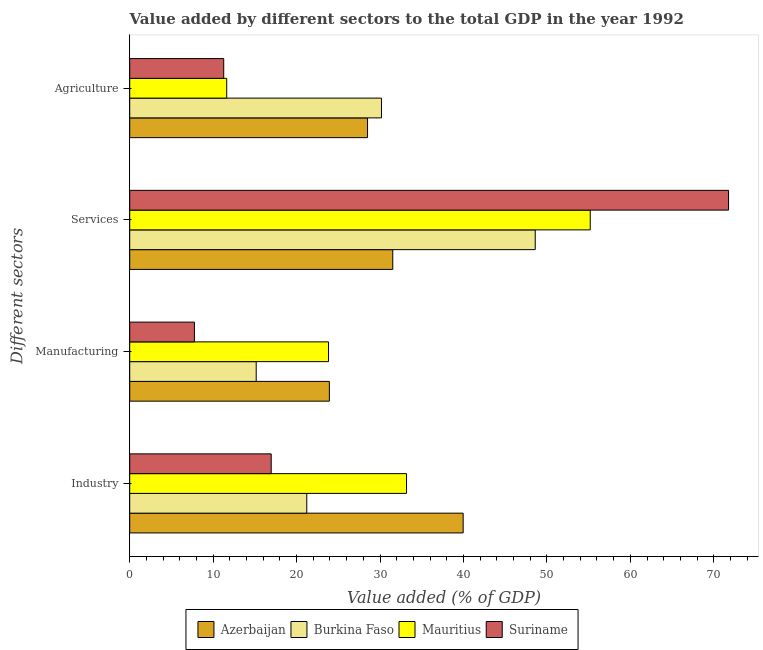How many different coloured bars are there?
Ensure brevity in your answer.  4. How many groups of bars are there?
Provide a succinct answer. 4. Are the number of bars per tick equal to the number of legend labels?
Ensure brevity in your answer.  Yes. How many bars are there on the 2nd tick from the top?
Your answer should be very brief. 4. How many bars are there on the 3rd tick from the bottom?
Keep it short and to the point. 4. What is the label of the 2nd group of bars from the top?
Keep it short and to the point. Services. What is the value added by services sector in Mauritius?
Give a very brief answer. 55.2. Across all countries, what is the maximum value added by manufacturing sector?
Your answer should be very brief. 23.93. Across all countries, what is the minimum value added by services sector?
Your answer should be compact. 31.53. In which country was the value added by services sector maximum?
Provide a succinct answer. Suriname. In which country was the value added by agricultural sector minimum?
Give a very brief answer. Suriname. What is the total value added by agricultural sector in the graph?
Your answer should be very brief. 81.57. What is the difference between the value added by industrial sector in Suriname and that in Burkina Faso?
Your answer should be compact. -4.26. What is the difference between the value added by agricultural sector in Burkina Faso and the value added by manufacturing sector in Suriname?
Your answer should be compact. 22.42. What is the average value added by manufacturing sector per country?
Give a very brief answer. 17.67. What is the difference between the value added by industrial sector and value added by agricultural sector in Mauritius?
Your answer should be very brief. 21.55. What is the ratio of the value added by manufacturing sector in Mauritius to that in Azerbaijan?
Ensure brevity in your answer.  1. Is the value added by industrial sector in Suriname less than that in Mauritius?
Your answer should be very brief. Yes. Is the difference between the value added by industrial sector in Burkina Faso and Azerbaijan greater than the difference between the value added by agricultural sector in Burkina Faso and Azerbaijan?
Ensure brevity in your answer.  No. What is the difference between the highest and the second highest value added by agricultural sector?
Your answer should be very brief. 1.67. What is the difference between the highest and the lowest value added by industrial sector?
Make the answer very short. 23.01. In how many countries, is the value added by agricultural sector greater than the average value added by agricultural sector taken over all countries?
Your response must be concise. 2. Is the sum of the value added by industrial sector in Mauritius and Suriname greater than the maximum value added by manufacturing sector across all countries?
Provide a short and direct response. Yes. Is it the case that in every country, the sum of the value added by services sector and value added by agricultural sector is greater than the sum of value added by manufacturing sector and value added by industrial sector?
Keep it short and to the point. Yes. What does the 2nd bar from the top in Manufacturing represents?
Your answer should be compact. Mauritius. What does the 2nd bar from the bottom in Services represents?
Ensure brevity in your answer.  Burkina Faso. Is it the case that in every country, the sum of the value added by industrial sector and value added by manufacturing sector is greater than the value added by services sector?
Provide a succinct answer. No. How many bars are there?
Provide a succinct answer. 16. Does the graph contain grids?
Your response must be concise. No. Where does the legend appear in the graph?
Give a very brief answer. Bottom center. How many legend labels are there?
Ensure brevity in your answer.  4. What is the title of the graph?
Offer a terse response. Value added by different sectors to the total GDP in the year 1992. What is the label or title of the X-axis?
Provide a succinct answer. Value added (% of GDP). What is the label or title of the Y-axis?
Your response must be concise. Different sectors. What is the Value added (% of GDP) of Azerbaijan in Industry?
Offer a terse response. 39.97. What is the Value added (% of GDP) in Burkina Faso in Industry?
Provide a succinct answer. 21.22. What is the Value added (% of GDP) in Mauritius in Industry?
Ensure brevity in your answer.  33.18. What is the Value added (% of GDP) of Suriname in Industry?
Provide a succinct answer. 16.96. What is the Value added (% of GDP) in Azerbaijan in Manufacturing?
Give a very brief answer. 23.93. What is the Value added (% of GDP) in Burkina Faso in Manufacturing?
Offer a terse response. 15.16. What is the Value added (% of GDP) of Mauritius in Manufacturing?
Offer a very short reply. 23.83. What is the Value added (% of GDP) in Suriname in Manufacturing?
Your response must be concise. 7.76. What is the Value added (% of GDP) of Azerbaijan in Services?
Provide a succinct answer. 31.53. What is the Value added (% of GDP) of Burkina Faso in Services?
Make the answer very short. 48.61. What is the Value added (% of GDP) in Mauritius in Services?
Your answer should be compact. 55.2. What is the Value added (% of GDP) of Suriname in Services?
Provide a succinct answer. 71.78. What is the Value added (% of GDP) in Azerbaijan in Agriculture?
Make the answer very short. 28.51. What is the Value added (% of GDP) in Burkina Faso in Agriculture?
Keep it short and to the point. 30.17. What is the Value added (% of GDP) of Mauritius in Agriculture?
Provide a succinct answer. 11.63. What is the Value added (% of GDP) of Suriname in Agriculture?
Your answer should be very brief. 11.27. Across all Different sectors, what is the maximum Value added (% of GDP) of Azerbaijan?
Keep it short and to the point. 39.97. Across all Different sectors, what is the maximum Value added (% of GDP) in Burkina Faso?
Keep it short and to the point. 48.61. Across all Different sectors, what is the maximum Value added (% of GDP) of Mauritius?
Keep it short and to the point. 55.2. Across all Different sectors, what is the maximum Value added (% of GDP) of Suriname?
Keep it short and to the point. 71.78. Across all Different sectors, what is the minimum Value added (% of GDP) of Azerbaijan?
Offer a terse response. 23.93. Across all Different sectors, what is the minimum Value added (% of GDP) in Burkina Faso?
Provide a short and direct response. 15.16. Across all Different sectors, what is the minimum Value added (% of GDP) in Mauritius?
Make the answer very short. 11.63. Across all Different sectors, what is the minimum Value added (% of GDP) in Suriname?
Offer a terse response. 7.76. What is the total Value added (% of GDP) in Azerbaijan in the graph?
Give a very brief answer. 123.93. What is the total Value added (% of GDP) in Burkina Faso in the graph?
Ensure brevity in your answer.  115.16. What is the total Value added (% of GDP) in Mauritius in the graph?
Your answer should be very brief. 123.83. What is the total Value added (% of GDP) of Suriname in the graph?
Make the answer very short. 107.75. What is the difference between the Value added (% of GDP) in Azerbaijan in Industry and that in Manufacturing?
Ensure brevity in your answer.  16.04. What is the difference between the Value added (% of GDP) in Burkina Faso in Industry and that in Manufacturing?
Give a very brief answer. 6.06. What is the difference between the Value added (% of GDP) of Mauritius in Industry and that in Manufacturing?
Offer a terse response. 9.35. What is the difference between the Value added (% of GDP) in Suriname in Industry and that in Manufacturing?
Your response must be concise. 9.2. What is the difference between the Value added (% of GDP) in Azerbaijan in Industry and that in Services?
Make the answer very short. 8.44. What is the difference between the Value added (% of GDP) in Burkina Faso in Industry and that in Services?
Make the answer very short. -27.39. What is the difference between the Value added (% of GDP) of Mauritius in Industry and that in Services?
Give a very brief answer. -22.02. What is the difference between the Value added (% of GDP) of Suriname in Industry and that in Services?
Provide a succinct answer. -54.82. What is the difference between the Value added (% of GDP) of Azerbaijan in Industry and that in Agriculture?
Ensure brevity in your answer.  11.46. What is the difference between the Value added (% of GDP) in Burkina Faso in Industry and that in Agriculture?
Provide a succinct answer. -8.96. What is the difference between the Value added (% of GDP) in Mauritius in Industry and that in Agriculture?
Provide a short and direct response. 21.55. What is the difference between the Value added (% of GDP) of Suriname in Industry and that in Agriculture?
Keep it short and to the point. 5.69. What is the difference between the Value added (% of GDP) of Azerbaijan in Manufacturing and that in Services?
Offer a terse response. -7.6. What is the difference between the Value added (% of GDP) of Burkina Faso in Manufacturing and that in Services?
Give a very brief answer. -33.45. What is the difference between the Value added (% of GDP) of Mauritius in Manufacturing and that in Services?
Ensure brevity in your answer.  -31.37. What is the difference between the Value added (% of GDP) of Suriname in Manufacturing and that in Services?
Your answer should be compact. -64.02. What is the difference between the Value added (% of GDP) of Azerbaijan in Manufacturing and that in Agriculture?
Make the answer very short. -4.58. What is the difference between the Value added (% of GDP) in Burkina Faso in Manufacturing and that in Agriculture?
Your answer should be compact. -15.02. What is the difference between the Value added (% of GDP) in Mauritius in Manufacturing and that in Agriculture?
Your response must be concise. 12.2. What is the difference between the Value added (% of GDP) in Suriname in Manufacturing and that in Agriculture?
Make the answer very short. -3.51. What is the difference between the Value added (% of GDP) of Azerbaijan in Services and that in Agriculture?
Your response must be concise. 3.02. What is the difference between the Value added (% of GDP) of Burkina Faso in Services and that in Agriculture?
Your answer should be compact. 18.43. What is the difference between the Value added (% of GDP) of Mauritius in Services and that in Agriculture?
Make the answer very short. 43.57. What is the difference between the Value added (% of GDP) of Suriname in Services and that in Agriculture?
Make the answer very short. 60.51. What is the difference between the Value added (% of GDP) of Azerbaijan in Industry and the Value added (% of GDP) of Burkina Faso in Manufacturing?
Your answer should be compact. 24.81. What is the difference between the Value added (% of GDP) in Azerbaijan in Industry and the Value added (% of GDP) in Mauritius in Manufacturing?
Provide a succinct answer. 16.14. What is the difference between the Value added (% of GDP) in Azerbaijan in Industry and the Value added (% of GDP) in Suriname in Manufacturing?
Your answer should be very brief. 32.21. What is the difference between the Value added (% of GDP) of Burkina Faso in Industry and the Value added (% of GDP) of Mauritius in Manufacturing?
Offer a very short reply. -2.61. What is the difference between the Value added (% of GDP) in Burkina Faso in Industry and the Value added (% of GDP) in Suriname in Manufacturing?
Your answer should be very brief. 13.46. What is the difference between the Value added (% of GDP) of Mauritius in Industry and the Value added (% of GDP) of Suriname in Manufacturing?
Provide a short and direct response. 25.42. What is the difference between the Value added (% of GDP) in Azerbaijan in Industry and the Value added (% of GDP) in Burkina Faso in Services?
Your answer should be very brief. -8.64. What is the difference between the Value added (% of GDP) of Azerbaijan in Industry and the Value added (% of GDP) of Mauritius in Services?
Your response must be concise. -15.23. What is the difference between the Value added (% of GDP) in Azerbaijan in Industry and the Value added (% of GDP) in Suriname in Services?
Keep it short and to the point. -31.81. What is the difference between the Value added (% of GDP) of Burkina Faso in Industry and the Value added (% of GDP) of Mauritius in Services?
Your answer should be compact. -33.98. What is the difference between the Value added (% of GDP) of Burkina Faso in Industry and the Value added (% of GDP) of Suriname in Services?
Give a very brief answer. -50.56. What is the difference between the Value added (% of GDP) of Mauritius in Industry and the Value added (% of GDP) of Suriname in Services?
Your answer should be very brief. -38.6. What is the difference between the Value added (% of GDP) in Azerbaijan in Industry and the Value added (% of GDP) in Burkina Faso in Agriculture?
Your response must be concise. 9.79. What is the difference between the Value added (% of GDP) in Azerbaijan in Industry and the Value added (% of GDP) in Mauritius in Agriculture?
Make the answer very short. 28.34. What is the difference between the Value added (% of GDP) of Azerbaijan in Industry and the Value added (% of GDP) of Suriname in Agriculture?
Your answer should be compact. 28.7. What is the difference between the Value added (% of GDP) in Burkina Faso in Industry and the Value added (% of GDP) in Mauritius in Agriculture?
Your answer should be compact. 9.59. What is the difference between the Value added (% of GDP) in Burkina Faso in Industry and the Value added (% of GDP) in Suriname in Agriculture?
Provide a short and direct response. 9.95. What is the difference between the Value added (% of GDP) of Mauritius in Industry and the Value added (% of GDP) of Suriname in Agriculture?
Your answer should be very brief. 21.91. What is the difference between the Value added (% of GDP) of Azerbaijan in Manufacturing and the Value added (% of GDP) of Burkina Faso in Services?
Give a very brief answer. -24.67. What is the difference between the Value added (% of GDP) of Azerbaijan in Manufacturing and the Value added (% of GDP) of Mauritius in Services?
Keep it short and to the point. -31.27. What is the difference between the Value added (% of GDP) of Azerbaijan in Manufacturing and the Value added (% of GDP) of Suriname in Services?
Your response must be concise. -47.85. What is the difference between the Value added (% of GDP) in Burkina Faso in Manufacturing and the Value added (% of GDP) in Mauritius in Services?
Give a very brief answer. -40.04. What is the difference between the Value added (% of GDP) in Burkina Faso in Manufacturing and the Value added (% of GDP) in Suriname in Services?
Ensure brevity in your answer.  -56.62. What is the difference between the Value added (% of GDP) in Mauritius in Manufacturing and the Value added (% of GDP) in Suriname in Services?
Your answer should be very brief. -47.95. What is the difference between the Value added (% of GDP) of Azerbaijan in Manufacturing and the Value added (% of GDP) of Burkina Faso in Agriculture?
Your response must be concise. -6.24. What is the difference between the Value added (% of GDP) in Azerbaijan in Manufacturing and the Value added (% of GDP) in Mauritius in Agriculture?
Provide a succinct answer. 12.3. What is the difference between the Value added (% of GDP) in Azerbaijan in Manufacturing and the Value added (% of GDP) in Suriname in Agriculture?
Provide a succinct answer. 12.66. What is the difference between the Value added (% of GDP) in Burkina Faso in Manufacturing and the Value added (% of GDP) in Mauritius in Agriculture?
Provide a succinct answer. 3.53. What is the difference between the Value added (% of GDP) of Burkina Faso in Manufacturing and the Value added (% of GDP) of Suriname in Agriculture?
Offer a very short reply. 3.89. What is the difference between the Value added (% of GDP) in Mauritius in Manufacturing and the Value added (% of GDP) in Suriname in Agriculture?
Offer a very short reply. 12.56. What is the difference between the Value added (% of GDP) of Azerbaijan in Services and the Value added (% of GDP) of Burkina Faso in Agriculture?
Keep it short and to the point. 1.35. What is the difference between the Value added (% of GDP) in Azerbaijan in Services and the Value added (% of GDP) in Mauritius in Agriculture?
Provide a succinct answer. 19.9. What is the difference between the Value added (% of GDP) in Azerbaijan in Services and the Value added (% of GDP) in Suriname in Agriculture?
Offer a very short reply. 20.26. What is the difference between the Value added (% of GDP) in Burkina Faso in Services and the Value added (% of GDP) in Mauritius in Agriculture?
Offer a terse response. 36.98. What is the difference between the Value added (% of GDP) in Burkina Faso in Services and the Value added (% of GDP) in Suriname in Agriculture?
Provide a succinct answer. 37.34. What is the difference between the Value added (% of GDP) in Mauritius in Services and the Value added (% of GDP) in Suriname in Agriculture?
Keep it short and to the point. 43.93. What is the average Value added (% of GDP) of Azerbaijan per Different sectors?
Give a very brief answer. 30.98. What is the average Value added (% of GDP) in Burkina Faso per Different sectors?
Your answer should be very brief. 28.79. What is the average Value added (% of GDP) in Mauritius per Different sectors?
Offer a terse response. 30.96. What is the average Value added (% of GDP) in Suriname per Different sectors?
Make the answer very short. 26.94. What is the difference between the Value added (% of GDP) of Azerbaijan and Value added (% of GDP) of Burkina Faso in Industry?
Offer a very short reply. 18.75. What is the difference between the Value added (% of GDP) in Azerbaijan and Value added (% of GDP) in Mauritius in Industry?
Make the answer very short. 6.79. What is the difference between the Value added (% of GDP) in Azerbaijan and Value added (% of GDP) in Suriname in Industry?
Provide a succinct answer. 23.01. What is the difference between the Value added (% of GDP) of Burkina Faso and Value added (% of GDP) of Mauritius in Industry?
Give a very brief answer. -11.96. What is the difference between the Value added (% of GDP) in Burkina Faso and Value added (% of GDP) in Suriname in Industry?
Provide a short and direct response. 4.26. What is the difference between the Value added (% of GDP) in Mauritius and Value added (% of GDP) in Suriname in Industry?
Give a very brief answer. 16.22. What is the difference between the Value added (% of GDP) of Azerbaijan and Value added (% of GDP) of Burkina Faso in Manufacturing?
Your response must be concise. 8.77. What is the difference between the Value added (% of GDP) of Azerbaijan and Value added (% of GDP) of Mauritius in Manufacturing?
Your response must be concise. 0.1. What is the difference between the Value added (% of GDP) of Azerbaijan and Value added (% of GDP) of Suriname in Manufacturing?
Give a very brief answer. 16.18. What is the difference between the Value added (% of GDP) of Burkina Faso and Value added (% of GDP) of Mauritius in Manufacturing?
Provide a short and direct response. -8.67. What is the difference between the Value added (% of GDP) in Burkina Faso and Value added (% of GDP) in Suriname in Manufacturing?
Your answer should be compact. 7.4. What is the difference between the Value added (% of GDP) of Mauritius and Value added (% of GDP) of Suriname in Manufacturing?
Keep it short and to the point. 16.07. What is the difference between the Value added (% of GDP) of Azerbaijan and Value added (% of GDP) of Burkina Faso in Services?
Your response must be concise. -17.08. What is the difference between the Value added (% of GDP) of Azerbaijan and Value added (% of GDP) of Mauritius in Services?
Ensure brevity in your answer.  -23.67. What is the difference between the Value added (% of GDP) of Azerbaijan and Value added (% of GDP) of Suriname in Services?
Offer a terse response. -40.25. What is the difference between the Value added (% of GDP) of Burkina Faso and Value added (% of GDP) of Mauritius in Services?
Offer a terse response. -6.59. What is the difference between the Value added (% of GDP) of Burkina Faso and Value added (% of GDP) of Suriname in Services?
Provide a short and direct response. -23.17. What is the difference between the Value added (% of GDP) of Mauritius and Value added (% of GDP) of Suriname in Services?
Provide a short and direct response. -16.58. What is the difference between the Value added (% of GDP) of Azerbaijan and Value added (% of GDP) of Burkina Faso in Agriculture?
Offer a terse response. -1.67. What is the difference between the Value added (% of GDP) of Azerbaijan and Value added (% of GDP) of Mauritius in Agriculture?
Ensure brevity in your answer.  16.88. What is the difference between the Value added (% of GDP) of Azerbaijan and Value added (% of GDP) of Suriname in Agriculture?
Your answer should be compact. 17.24. What is the difference between the Value added (% of GDP) of Burkina Faso and Value added (% of GDP) of Mauritius in Agriculture?
Keep it short and to the point. 18.55. What is the difference between the Value added (% of GDP) in Burkina Faso and Value added (% of GDP) in Suriname in Agriculture?
Offer a very short reply. 18.91. What is the difference between the Value added (% of GDP) in Mauritius and Value added (% of GDP) in Suriname in Agriculture?
Provide a short and direct response. 0.36. What is the ratio of the Value added (% of GDP) of Azerbaijan in Industry to that in Manufacturing?
Ensure brevity in your answer.  1.67. What is the ratio of the Value added (% of GDP) of Burkina Faso in Industry to that in Manufacturing?
Keep it short and to the point. 1.4. What is the ratio of the Value added (% of GDP) of Mauritius in Industry to that in Manufacturing?
Ensure brevity in your answer.  1.39. What is the ratio of the Value added (% of GDP) of Suriname in Industry to that in Manufacturing?
Provide a succinct answer. 2.19. What is the ratio of the Value added (% of GDP) of Azerbaijan in Industry to that in Services?
Keep it short and to the point. 1.27. What is the ratio of the Value added (% of GDP) of Burkina Faso in Industry to that in Services?
Give a very brief answer. 0.44. What is the ratio of the Value added (% of GDP) of Mauritius in Industry to that in Services?
Ensure brevity in your answer.  0.6. What is the ratio of the Value added (% of GDP) of Suriname in Industry to that in Services?
Offer a very short reply. 0.24. What is the ratio of the Value added (% of GDP) in Azerbaijan in Industry to that in Agriculture?
Keep it short and to the point. 1.4. What is the ratio of the Value added (% of GDP) of Burkina Faso in Industry to that in Agriculture?
Provide a short and direct response. 0.7. What is the ratio of the Value added (% of GDP) of Mauritius in Industry to that in Agriculture?
Ensure brevity in your answer.  2.85. What is the ratio of the Value added (% of GDP) of Suriname in Industry to that in Agriculture?
Give a very brief answer. 1.51. What is the ratio of the Value added (% of GDP) in Azerbaijan in Manufacturing to that in Services?
Ensure brevity in your answer.  0.76. What is the ratio of the Value added (% of GDP) of Burkina Faso in Manufacturing to that in Services?
Ensure brevity in your answer.  0.31. What is the ratio of the Value added (% of GDP) in Mauritius in Manufacturing to that in Services?
Ensure brevity in your answer.  0.43. What is the ratio of the Value added (% of GDP) of Suriname in Manufacturing to that in Services?
Give a very brief answer. 0.11. What is the ratio of the Value added (% of GDP) of Azerbaijan in Manufacturing to that in Agriculture?
Your answer should be very brief. 0.84. What is the ratio of the Value added (% of GDP) in Burkina Faso in Manufacturing to that in Agriculture?
Offer a terse response. 0.5. What is the ratio of the Value added (% of GDP) in Mauritius in Manufacturing to that in Agriculture?
Provide a succinct answer. 2.05. What is the ratio of the Value added (% of GDP) in Suriname in Manufacturing to that in Agriculture?
Your answer should be very brief. 0.69. What is the ratio of the Value added (% of GDP) in Azerbaijan in Services to that in Agriculture?
Keep it short and to the point. 1.11. What is the ratio of the Value added (% of GDP) in Burkina Faso in Services to that in Agriculture?
Offer a terse response. 1.61. What is the ratio of the Value added (% of GDP) in Mauritius in Services to that in Agriculture?
Your response must be concise. 4.75. What is the ratio of the Value added (% of GDP) in Suriname in Services to that in Agriculture?
Offer a very short reply. 6.37. What is the difference between the highest and the second highest Value added (% of GDP) in Azerbaijan?
Your answer should be compact. 8.44. What is the difference between the highest and the second highest Value added (% of GDP) in Burkina Faso?
Your answer should be very brief. 18.43. What is the difference between the highest and the second highest Value added (% of GDP) in Mauritius?
Keep it short and to the point. 22.02. What is the difference between the highest and the second highest Value added (% of GDP) in Suriname?
Keep it short and to the point. 54.82. What is the difference between the highest and the lowest Value added (% of GDP) of Azerbaijan?
Offer a terse response. 16.04. What is the difference between the highest and the lowest Value added (% of GDP) in Burkina Faso?
Your answer should be very brief. 33.45. What is the difference between the highest and the lowest Value added (% of GDP) of Mauritius?
Offer a terse response. 43.57. What is the difference between the highest and the lowest Value added (% of GDP) in Suriname?
Give a very brief answer. 64.02. 